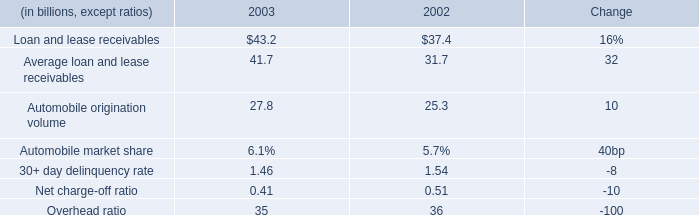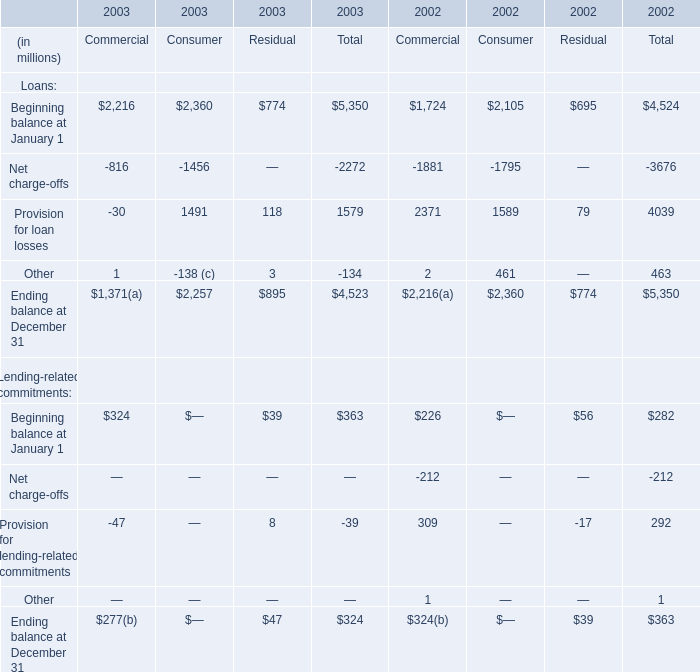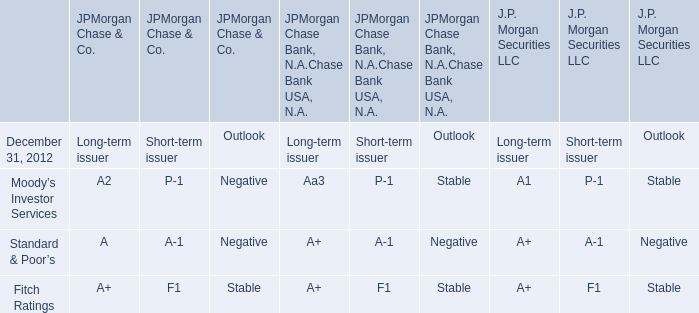what was the decline from 2002 to 2003 in interest income , in us$ b? 
Computations: ((1.7 / (1 - 11%)) - 1.7)
Answer: 0.21011. 